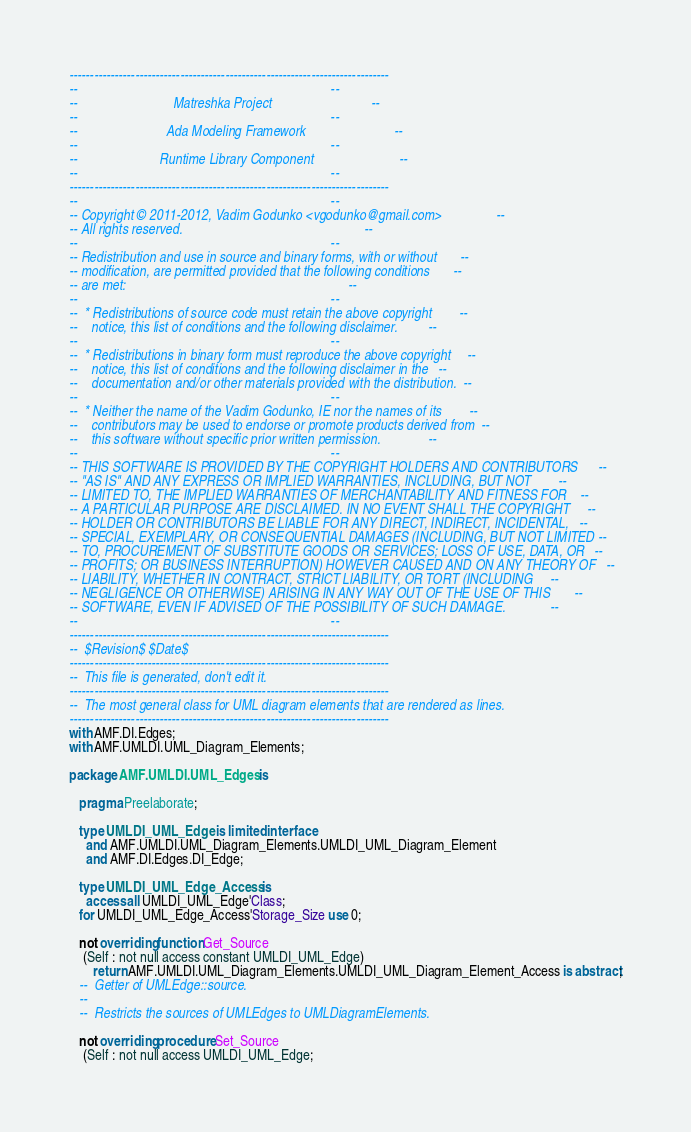<code> <loc_0><loc_0><loc_500><loc_500><_Ada_>------------------------------------------------------------------------------
--                                                                          --
--                            Matreshka Project                             --
--                                                                          --
--                          Ada Modeling Framework                          --
--                                                                          --
--                        Runtime Library Component                         --
--                                                                          --
------------------------------------------------------------------------------
--                                                                          --
-- Copyright © 2011-2012, Vadim Godunko <vgodunko@gmail.com>                --
-- All rights reserved.                                                     --
--                                                                          --
-- Redistribution and use in source and binary forms, with or without       --
-- modification, are permitted provided that the following conditions       --
-- are met:                                                                 --
--                                                                          --
--  * Redistributions of source code must retain the above copyright        --
--    notice, this list of conditions and the following disclaimer.         --
--                                                                          --
--  * Redistributions in binary form must reproduce the above copyright     --
--    notice, this list of conditions and the following disclaimer in the   --
--    documentation and/or other materials provided with the distribution.  --
--                                                                          --
--  * Neither the name of the Vadim Godunko, IE nor the names of its        --
--    contributors may be used to endorse or promote products derived from  --
--    this software without specific prior written permission.              --
--                                                                          --
-- THIS SOFTWARE IS PROVIDED BY THE COPYRIGHT HOLDERS AND CONTRIBUTORS      --
-- "AS IS" AND ANY EXPRESS OR IMPLIED WARRANTIES, INCLUDING, BUT NOT        --
-- LIMITED TO, THE IMPLIED WARRANTIES OF MERCHANTABILITY AND FITNESS FOR    --
-- A PARTICULAR PURPOSE ARE DISCLAIMED. IN NO EVENT SHALL THE COPYRIGHT     --
-- HOLDER OR CONTRIBUTORS BE LIABLE FOR ANY DIRECT, INDIRECT, INCIDENTAL,   --
-- SPECIAL, EXEMPLARY, OR CONSEQUENTIAL DAMAGES (INCLUDING, BUT NOT LIMITED --
-- TO, PROCUREMENT OF SUBSTITUTE GOODS OR SERVICES; LOSS OF USE, DATA, OR   --
-- PROFITS; OR BUSINESS INTERRUPTION) HOWEVER CAUSED AND ON ANY THEORY OF   --
-- LIABILITY, WHETHER IN CONTRACT, STRICT LIABILITY, OR TORT (INCLUDING     --
-- NEGLIGENCE OR OTHERWISE) ARISING IN ANY WAY OUT OF THE USE OF THIS       --
-- SOFTWARE, EVEN IF ADVISED OF THE POSSIBILITY OF SUCH DAMAGE.             --
--                                                                          --
------------------------------------------------------------------------------
--  $Revision$ $Date$
------------------------------------------------------------------------------
--  This file is generated, don't edit it.
------------------------------------------------------------------------------
--  The most general class for UML diagram elements that are rendered as lines.
------------------------------------------------------------------------------
with AMF.DI.Edges;
with AMF.UMLDI.UML_Diagram_Elements;

package AMF.UMLDI.UML_Edges is

   pragma Preelaborate;

   type UMLDI_UML_Edge is limited interface
     and AMF.UMLDI.UML_Diagram_Elements.UMLDI_UML_Diagram_Element
     and AMF.DI.Edges.DI_Edge;

   type UMLDI_UML_Edge_Access is
     access all UMLDI_UML_Edge'Class;
   for UMLDI_UML_Edge_Access'Storage_Size use 0;

   not overriding function Get_Source
    (Self : not null access constant UMLDI_UML_Edge)
       return AMF.UMLDI.UML_Diagram_Elements.UMLDI_UML_Diagram_Element_Access is abstract;
   --  Getter of UMLEdge::source.
   --
   --  Restricts the sources of UMLEdges to UMLDiagramElements.

   not overriding procedure Set_Source
    (Self : not null access UMLDI_UML_Edge;</code> 